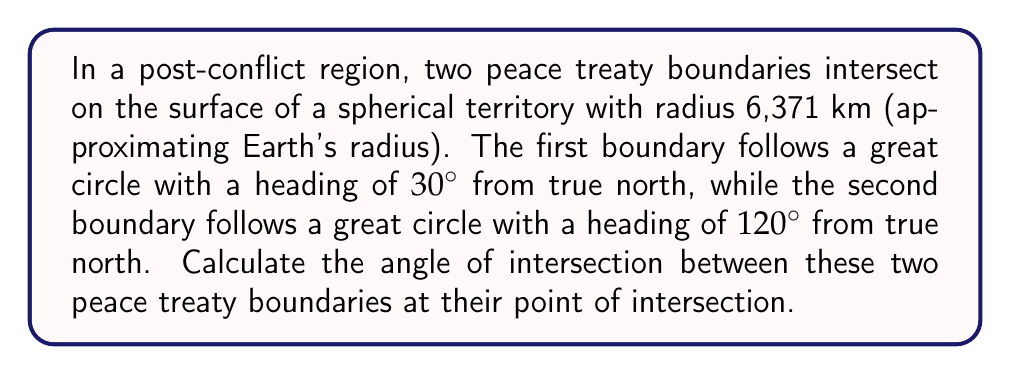What is the answer to this math problem? To solve this problem, we need to use concepts from spherical geometry:

1) In spherical geometry, great circles are the geodesics (shortest paths) on a sphere's surface. They are analogous to straight lines in planar geometry.

2) The angle between two great circles at their point of intersection is equal to the angle between their planes at the center of the sphere.

3) We can calculate this angle using the spherical law of cosines for angles:

   $$\cos(C) = -\cos(A)\cos(B) + \sin(A)\sin(B)\cos(c)$$

   Where $C$ is the angle we're seeking, $A$ and $B$ are the complements of the headings (90° - heading), and $c$ is the angular distance between the poles of the great circles (which is irrelevant in this case as it doesn't affect the intersection angle).

4) Let's calculate $A$ and $B$:
   $A = 90° - 30° = 60°$
   $B = 90° - 120° = -30°$

5) Plugging these into our formula:

   $$\cos(C) = -\cos(60°)\cos(-30°) + \sin(60°)\sin(-30°)\cos(c)$$

6) Simplify, noting that $\cos(-30°) = \cos(30°)$ and $\sin(-30°) = -\sin(30°)$:

   $$\cos(C) = -(\frac{1}{2})(\frac{\sqrt{3}}{2}) + (\frac{\sqrt{3}}{2})(-\frac{1}{2})\cos(c)$$

7) The $\cos(c)$ term cancels out:

   $$\cos(C) = -\frac{\sqrt{3}}{4} - \frac{\sqrt{3}}{4} = -\frac{\sqrt{3}}{2}$$

8) Taking the inverse cosine of both sides:

   $$C = \arccos(-\frac{\sqrt{3}}{2}) = 150°$$

Therefore, the angle of intersection between the two peace treaty boundaries is 150°.
Answer: 150° 